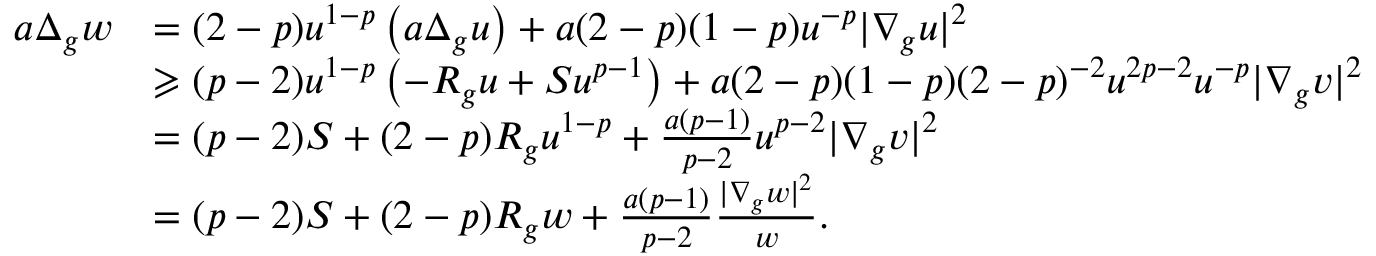<formula> <loc_0><loc_0><loc_500><loc_500>\begin{array} { r l } { a \Delta _ { g } w } & { = ( 2 - p ) u ^ { 1 - p } \left ( a \Delta _ { g } u \right ) + a ( 2 - p ) ( 1 - p ) u ^ { - p } | \nabla _ { g } u | ^ { 2 } } \\ & { \geqslant ( p - 2 ) u ^ { 1 - p } \left ( - R _ { g } u + S u ^ { p - 1 } \right ) + a ( 2 - p ) ( 1 - p ) ( 2 - p ) ^ { - 2 } u ^ { 2 p - 2 } u ^ { - p } | \nabla _ { g } v | ^ { 2 } } \\ & { = ( p - 2 ) S + ( 2 - p ) R _ { g } u ^ { 1 - p } + \frac { a ( p - 1 ) } { p - 2 } u ^ { p - 2 } | \nabla _ { g } v | ^ { 2 } } \\ & { = ( p - 2 ) S + ( 2 - p ) R _ { g } w + \frac { a ( p - 1 ) } { p - 2 } \frac { | \nabla _ { g } w | ^ { 2 } } { w } . } \end{array}</formula> 